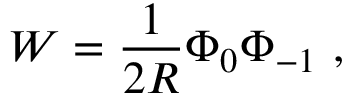Convert formula to latex. <formula><loc_0><loc_0><loc_500><loc_500>W = \frac { 1 } { 2 R } \Phi _ { 0 } \Phi _ { - 1 } \ ,</formula> 